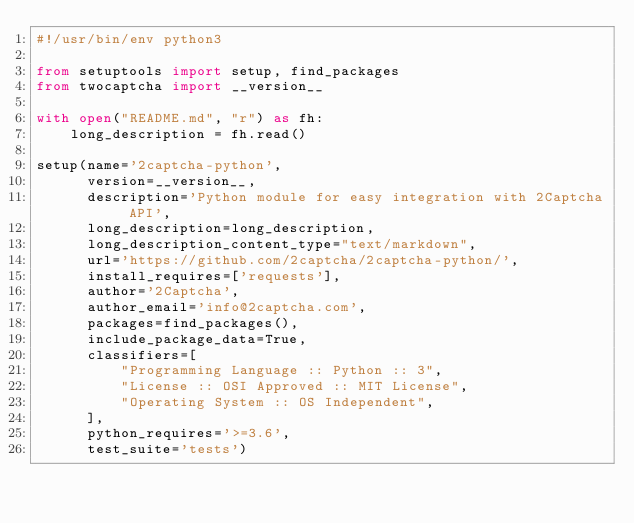<code> <loc_0><loc_0><loc_500><loc_500><_Python_>#!/usr/bin/env python3

from setuptools import setup, find_packages
from twocaptcha import __version__

with open("README.md", "r") as fh:
    long_description = fh.read()

setup(name='2captcha-python',
      version=__version__,
      description='Python module for easy integration with 2Captcha API',
      long_description=long_description,
      long_description_content_type="text/markdown",
      url='https://github.com/2captcha/2captcha-python/',
      install_requires=['requests'],
      author='2Captcha',
      author_email='info@2captcha.com',
      packages=find_packages(),
      include_package_data=True,
      classifiers=[
          "Programming Language :: Python :: 3",
          "License :: OSI Approved :: MIT License",
          "Operating System :: OS Independent",
      ],
      python_requires='>=3.6',
      test_suite='tests')
</code> 